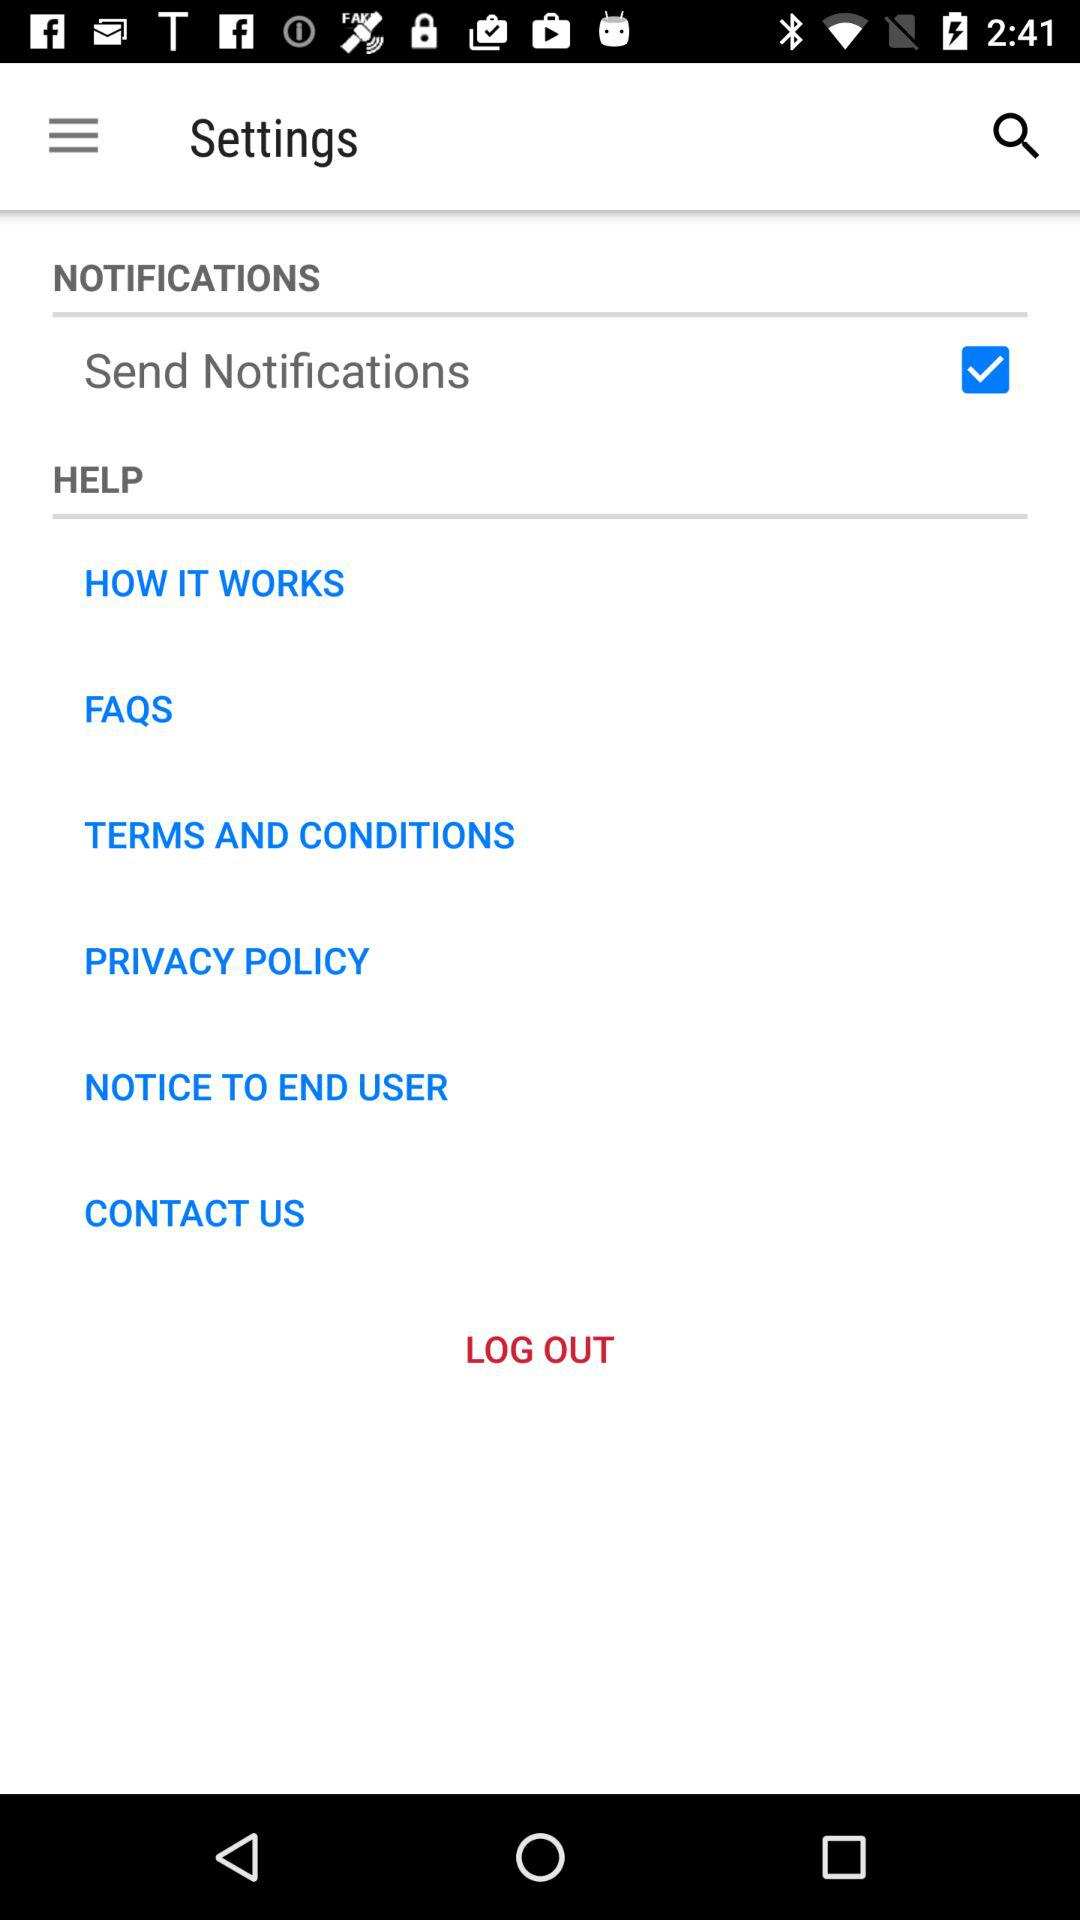What is the status of the "Send Notifications"? The status is "on". 